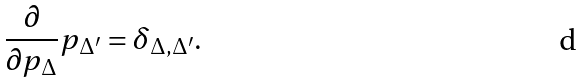Convert formula to latex. <formula><loc_0><loc_0><loc_500><loc_500>\frac { \partial } { \partial p _ { \Delta } } p _ { \Delta ^ { \prime } } = \delta _ { \Delta , \Delta ^ { \prime } } .</formula> 